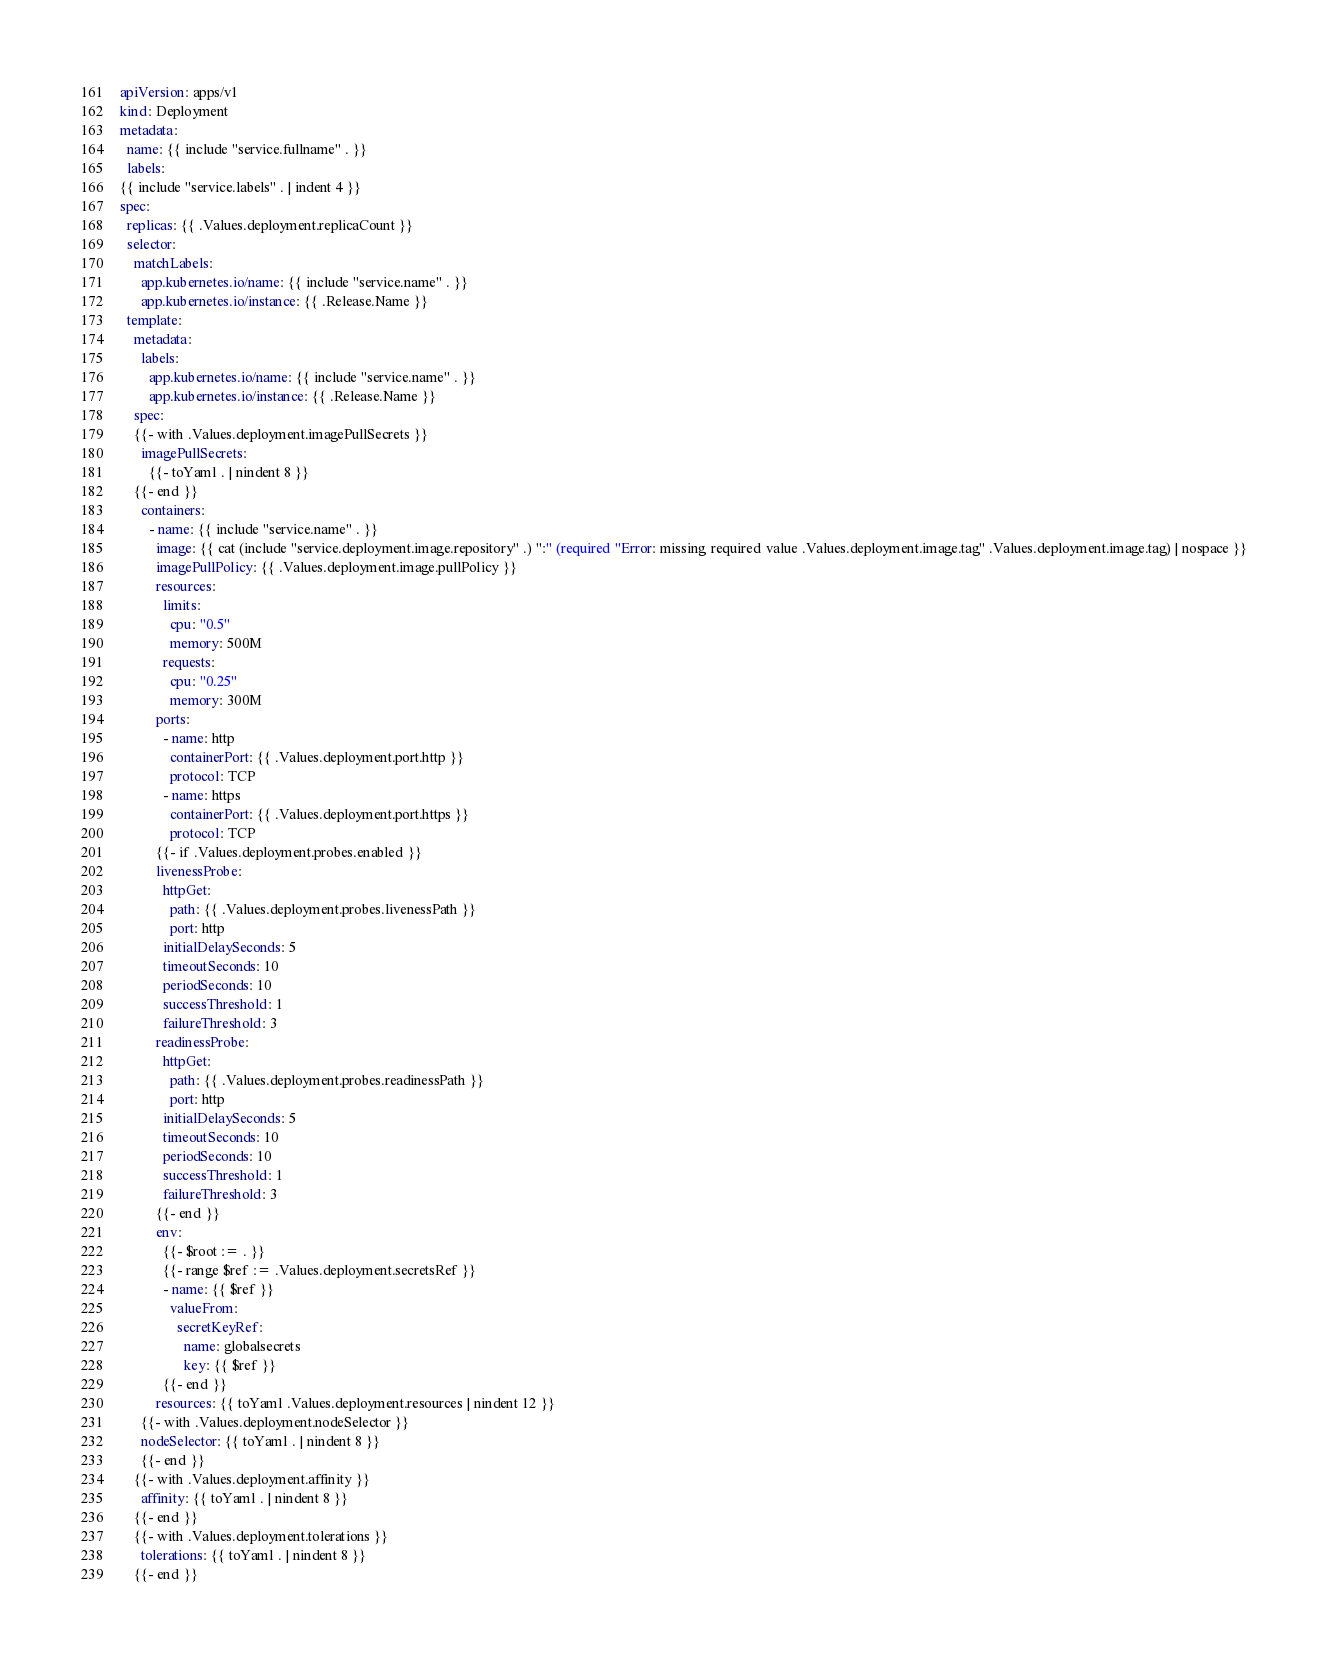<code> <loc_0><loc_0><loc_500><loc_500><_YAML_>apiVersion: apps/v1
kind: Deployment
metadata:
  name: {{ include "service.fullname" . }}
  labels:
{{ include "service.labels" . | indent 4 }}
spec:
  replicas: {{ .Values.deployment.replicaCount }}
  selector:
    matchLabels:
      app.kubernetes.io/name: {{ include "service.name" . }}
      app.kubernetes.io/instance: {{ .Release.Name }}
  template:
    metadata:
      labels:
        app.kubernetes.io/name: {{ include "service.name" . }}
        app.kubernetes.io/instance: {{ .Release.Name }}
    spec:
    {{- with .Values.deployment.imagePullSecrets }}
      imagePullSecrets:
        {{- toYaml . | nindent 8 }}
    {{- end }}
      containers:
        - name: {{ include "service.name" . }}
          image: {{ cat (include "service.deployment.image.repository" .) ":" (required "Error: missing required value .Values.deployment.image.tag" .Values.deployment.image.tag) | nospace }}
          imagePullPolicy: {{ .Values.deployment.image.pullPolicy }}
          resources:
            limits:
              cpu: "0.5"
              memory: 500M
            requests:
              cpu: "0.25"
              memory: 300M
          ports:
            - name: http
              containerPort: {{ .Values.deployment.port.http }}
              protocol: TCP
            - name: https
              containerPort: {{ .Values.deployment.port.https }}
              protocol: TCP
          {{- if .Values.deployment.probes.enabled }}
          livenessProbe:
            httpGet:
              path: {{ .Values.deployment.probes.livenessPath }}
              port: http
            initialDelaySeconds: 5
            timeoutSeconds: 10
            periodSeconds: 10
            successThreshold: 1
            failureThreshold: 3
          readinessProbe:
            httpGet:
              path: {{ .Values.deployment.probes.readinessPath }}
              port: http
            initialDelaySeconds: 5
            timeoutSeconds: 10
            periodSeconds: 10
            successThreshold: 1
            failureThreshold: 3
          {{- end }}
          env:
            {{- $root := . }}
            {{- range $ref := .Values.deployment.secretsRef }}
            - name: {{ $ref }}
              valueFrom:
                secretKeyRef:
                  name: globalsecrets
                  key: {{ $ref }}
            {{- end }}
          resources: {{ toYaml .Values.deployment.resources | nindent 12 }}
      {{- with .Values.deployment.nodeSelector }}
      nodeSelector: {{ toYaml . | nindent 8 }}
      {{- end }}
    {{- with .Values.deployment.affinity }}
      affinity: {{ toYaml . | nindent 8 }}
    {{- end }}
    {{- with .Values.deployment.tolerations }}
      tolerations: {{ toYaml . | nindent 8 }}
    {{- end }}
</code> 